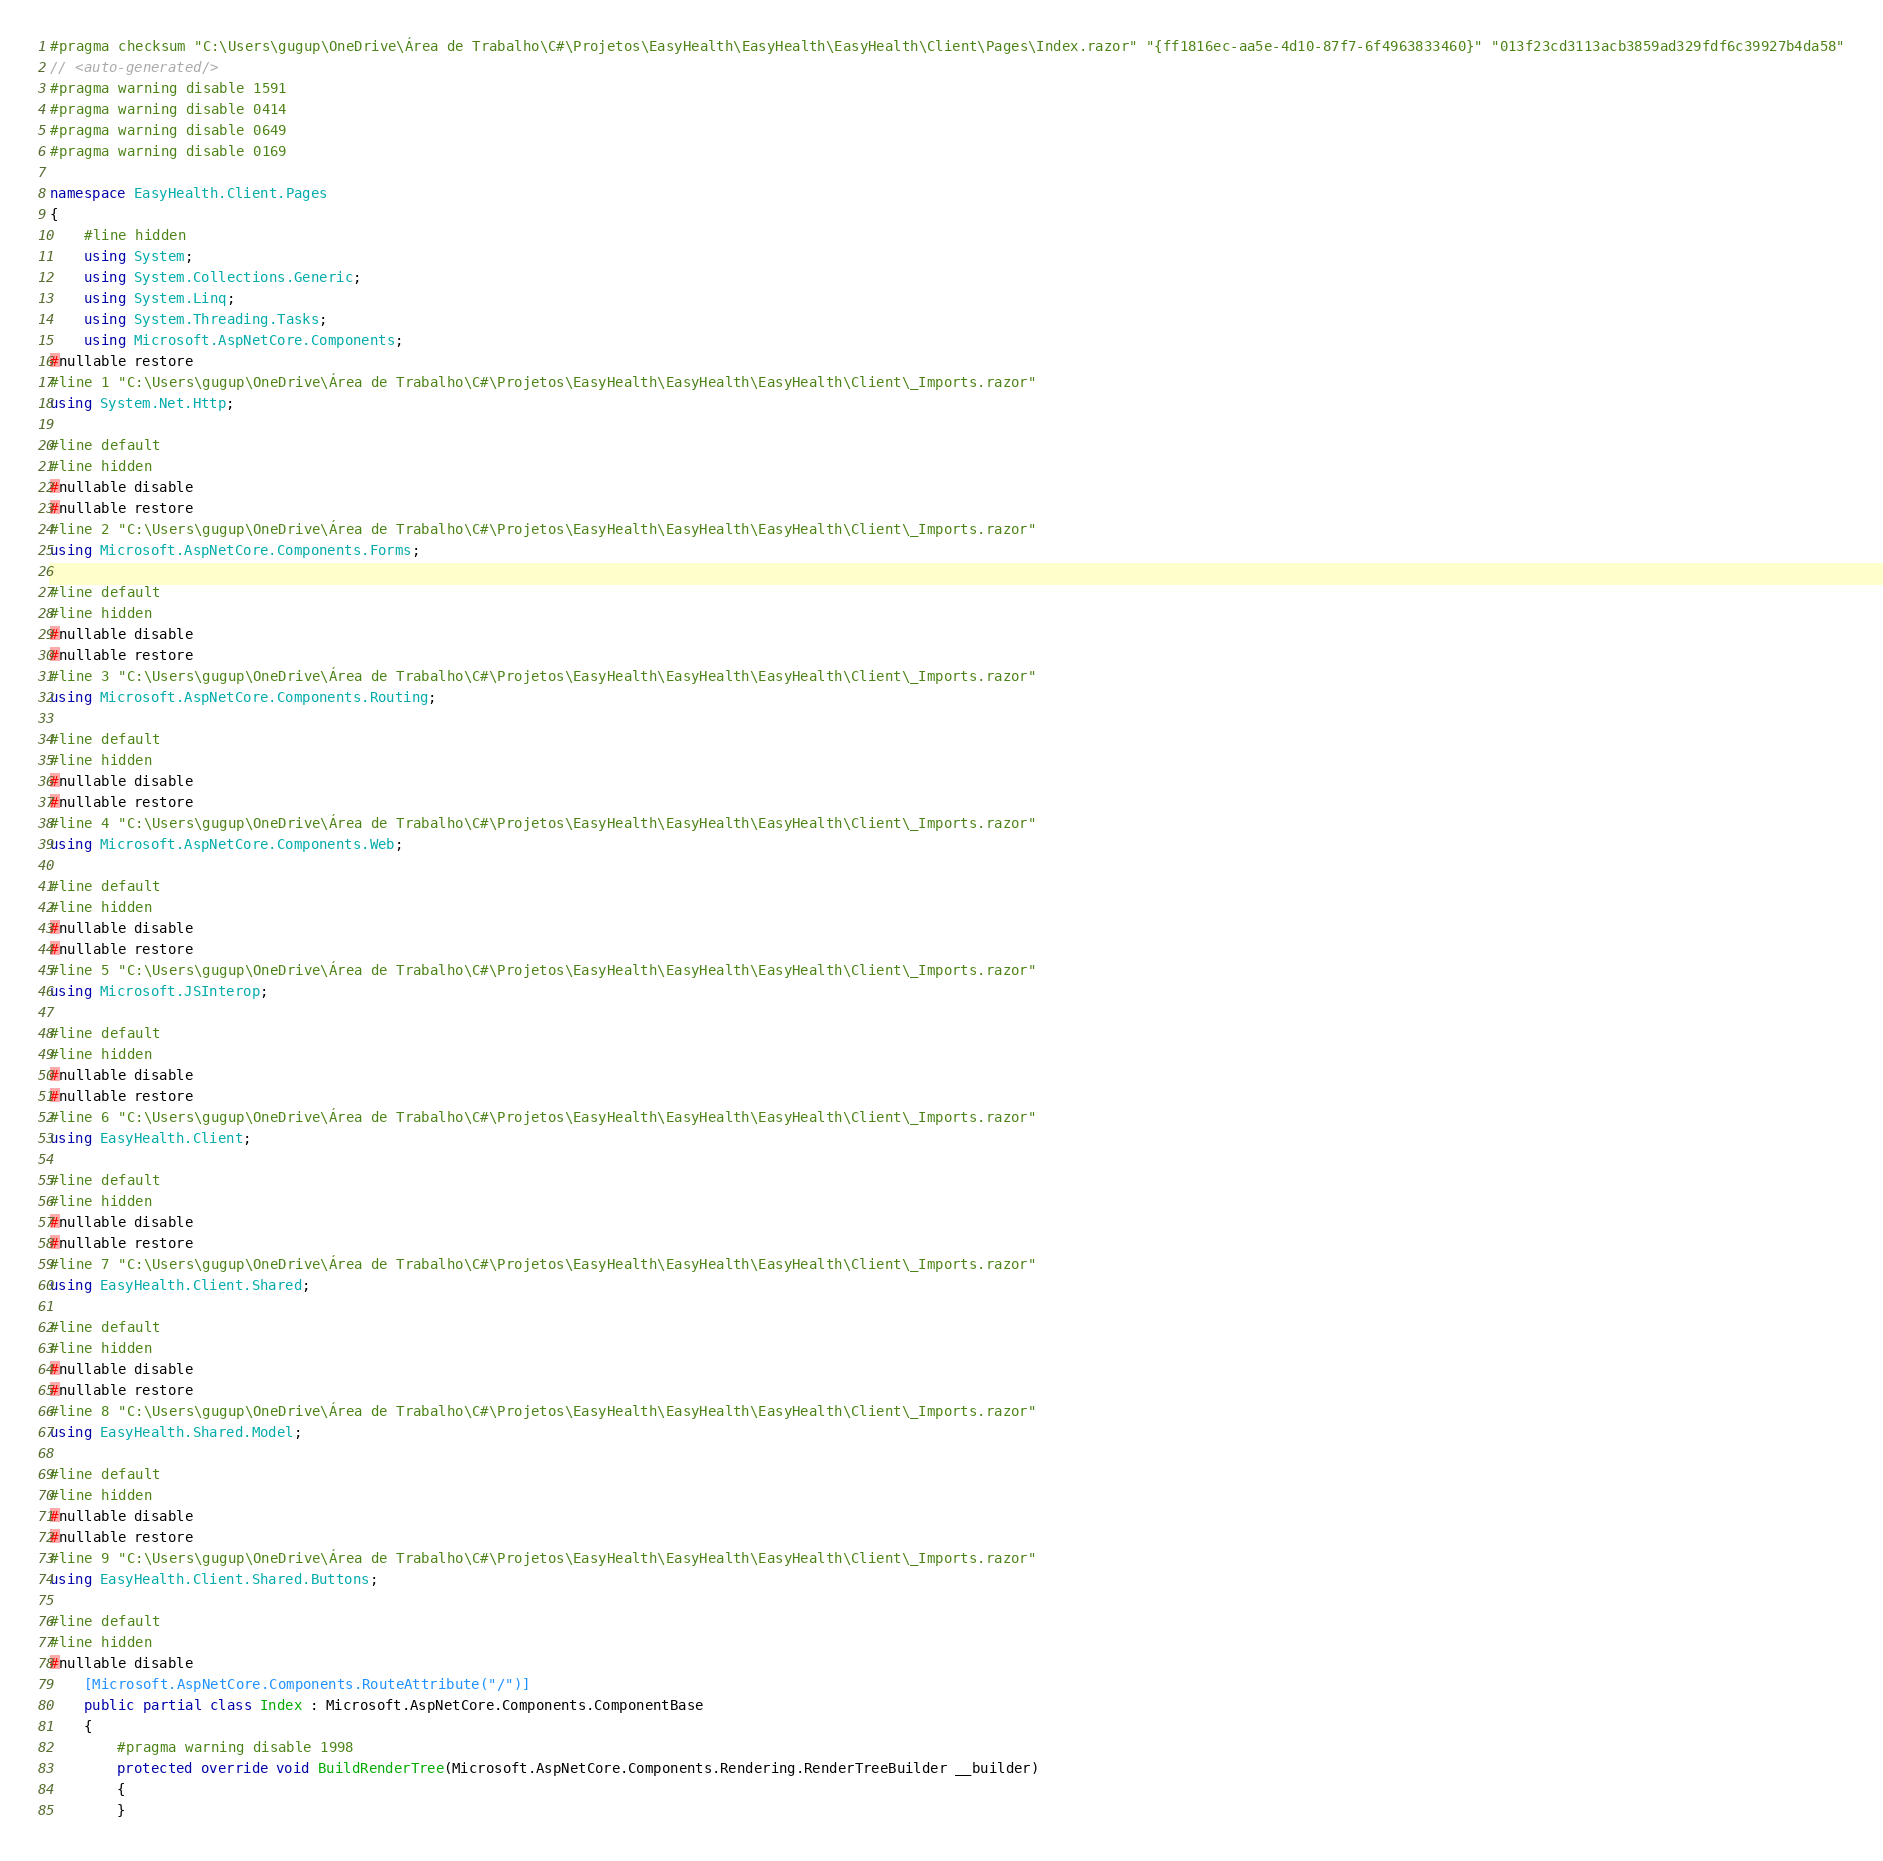<code> <loc_0><loc_0><loc_500><loc_500><_C#_>#pragma checksum "C:\Users\gugup\OneDrive\Área de Trabalho\C#\Projetos\EasyHealth\EasyHealth\EasyHealth\Client\Pages\Index.razor" "{ff1816ec-aa5e-4d10-87f7-6f4963833460}" "013f23cd3113acb3859ad329fdf6c39927b4da58"
// <auto-generated/>
#pragma warning disable 1591
#pragma warning disable 0414
#pragma warning disable 0649
#pragma warning disable 0169

namespace EasyHealth.Client.Pages
{
    #line hidden
    using System;
    using System.Collections.Generic;
    using System.Linq;
    using System.Threading.Tasks;
    using Microsoft.AspNetCore.Components;
#nullable restore
#line 1 "C:\Users\gugup\OneDrive\Área de Trabalho\C#\Projetos\EasyHealth\EasyHealth\EasyHealth\Client\_Imports.razor"
using System.Net.Http;

#line default
#line hidden
#nullable disable
#nullable restore
#line 2 "C:\Users\gugup\OneDrive\Área de Trabalho\C#\Projetos\EasyHealth\EasyHealth\EasyHealth\Client\_Imports.razor"
using Microsoft.AspNetCore.Components.Forms;

#line default
#line hidden
#nullable disable
#nullable restore
#line 3 "C:\Users\gugup\OneDrive\Área de Trabalho\C#\Projetos\EasyHealth\EasyHealth\EasyHealth\Client\_Imports.razor"
using Microsoft.AspNetCore.Components.Routing;

#line default
#line hidden
#nullable disable
#nullable restore
#line 4 "C:\Users\gugup\OneDrive\Área de Trabalho\C#\Projetos\EasyHealth\EasyHealth\EasyHealth\Client\_Imports.razor"
using Microsoft.AspNetCore.Components.Web;

#line default
#line hidden
#nullable disable
#nullable restore
#line 5 "C:\Users\gugup\OneDrive\Área de Trabalho\C#\Projetos\EasyHealth\EasyHealth\EasyHealth\Client\_Imports.razor"
using Microsoft.JSInterop;

#line default
#line hidden
#nullable disable
#nullable restore
#line 6 "C:\Users\gugup\OneDrive\Área de Trabalho\C#\Projetos\EasyHealth\EasyHealth\EasyHealth\Client\_Imports.razor"
using EasyHealth.Client;

#line default
#line hidden
#nullable disable
#nullable restore
#line 7 "C:\Users\gugup\OneDrive\Área de Trabalho\C#\Projetos\EasyHealth\EasyHealth\EasyHealth\Client\_Imports.razor"
using EasyHealth.Client.Shared;

#line default
#line hidden
#nullable disable
#nullable restore
#line 8 "C:\Users\gugup\OneDrive\Área de Trabalho\C#\Projetos\EasyHealth\EasyHealth\EasyHealth\Client\_Imports.razor"
using EasyHealth.Shared.Model;

#line default
#line hidden
#nullable disable
#nullable restore
#line 9 "C:\Users\gugup\OneDrive\Área de Trabalho\C#\Projetos\EasyHealth\EasyHealth\EasyHealth\Client\_Imports.razor"
using EasyHealth.Client.Shared.Buttons;

#line default
#line hidden
#nullable disable
    [Microsoft.AspNetCore.Components.RouteAttribute("/")]
    public partial class Index : Microsoft.AspNetCore.Components.ComponentBase
    {
        #pragma warning disable 1998
        protected override void BuildRenderTree(Microsoft.AspNetCore.Components.Rendering.RenderTreeBuilder __builder)
        {
        }</code> 